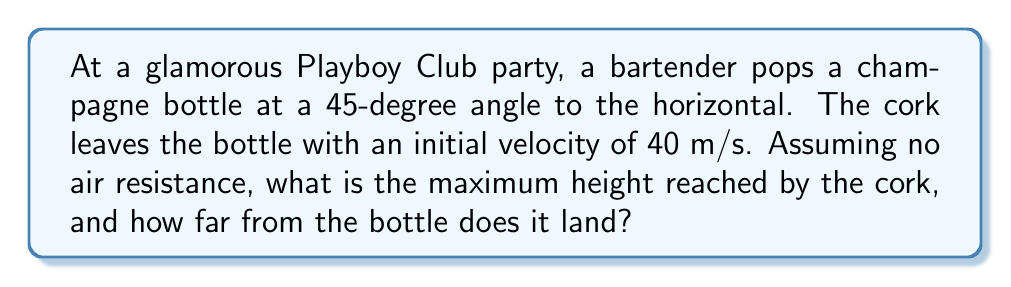Help me with this question. Let's approach this problem step-by-step using the principles of projectile motion:

1) First, let's break down the initial velocity into its horizontal and vertical components:
   
   $v_x = v_0 \cos \theta = 40 \cos 45° = 40 \cdot \frac{\sqrt{2}}{2} \approx 28.28$ m/s
   $v_y = v_0 \sin \theta = 40 \sin 45° = 40 \cdot \frac{\sqrt{2}}{2} \approx 28.28$ m/s

2) To find the maximum height, we use the equation:
   
   $h_{max} = \frac{v_y^2}{2g}$

   Where $g$ is the acceleration due to gravity (9.8 m/s²).

   $h_{max} = \frac{(28.28)^2}{2(9.8)} \approx 40.82$ m

3) To find the time of flight, we use:
   
   $t_{total} = \frac{2v_y}{g} = \frac{2(28.28)}{9.8} \approx 5.77$ s

4) To find the horizontal distance, we use:
   
   $d = v_x \cdot t_{total} = 28.28 \cdot 5.77 \approx 163.17$ m

Therefore, the cork reaches a maximum height of approximately 40.82 meters and lands about 163.17 meters away from the bottle.
Answer: Maximum height: 40.82 m; Distance: 163.17 m 